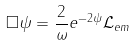Convert formula to latex. <formula><loc_0><loc_0><loc_500><loc_500>\square \psi = \frac { 2 } { \omega } e ^ { - 2 \psi } { \mathcal { L } } _ { e m }</formula> 